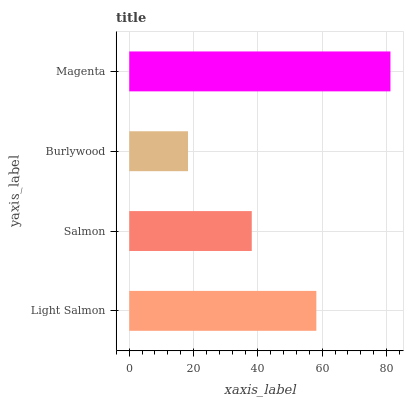Is Burlywood the minimum?
Answer yes or no. Yes. Is Magenta the maximum?
Answer yes or no. Yes. Is Salmon the minimum?
Answer yes or no. No. Is Salmon the maximum?
Answer yes or no. No. Is Light Salmon greater than Salmon?
Answer yes or no. Yes. Is Salmon less than Light Salmon?
Answer yes or no. Yes. Is Salmon greater than Light Salmon?
Answer yes or no. No. Is Light Salmon less than Salmon?
Answer yes or no. No. Is Light Salmon the high median?
Answer yes or no. Yes. Is Salmon the low median?
Answer yes or no. Yes. Is Salmon the high median?
Answer yes or no. No. Is Light Salmon the low median?
Answer yes or no. No. 